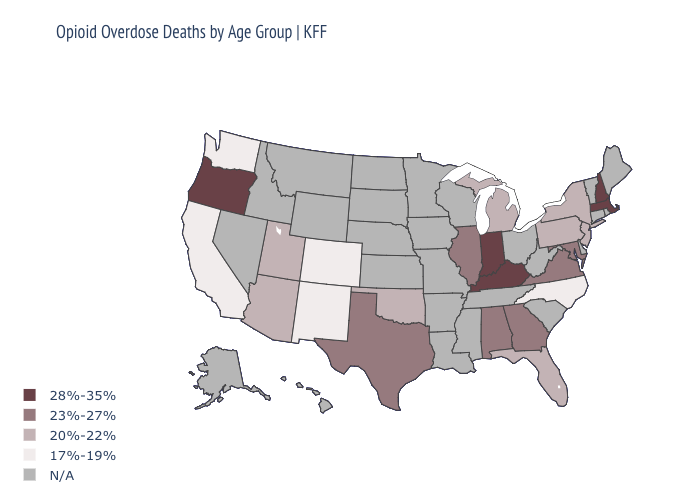What is the value of Kansas?
Quick response, please. N/A. Is the legend a continuous bar?
Concise answer only. No. What is the highest value in the West ?
Concise answer only. 28%-35%. Among the states that border Indiana , does Michigan have the lowest value?
Answer briefly. Yes. What is the value of Vermont?
Concise answer only. N/A. Which states have the lowest value in the USA?
Answer briefly. California, Colorado, New Mexico, North Carolina, Washington. What is the value of New Mexico?
Be succinct. 17%-19%. Does Massachusetts have the lowest value in the USA?
Keep it brief. No. Which states hav the highest value in the South?
Short answer required. Kentucky. Does the map have missing data?
Be succinct. Yes. What is the highest value in the USA?
Be succinct. 28%-35%. Does Michigan have the lowest value in the MidWest?
Write a very short answer. Yes. Among the states that border Nevada , does Oregon have the lowest value?
Give a very brief answer. No. What is the lowest value in the MidWest?
Give a very brief answer. 20%-22%. Among the states that border Virginia , does Maryland have the lowest value?
Keep it brief. No. 